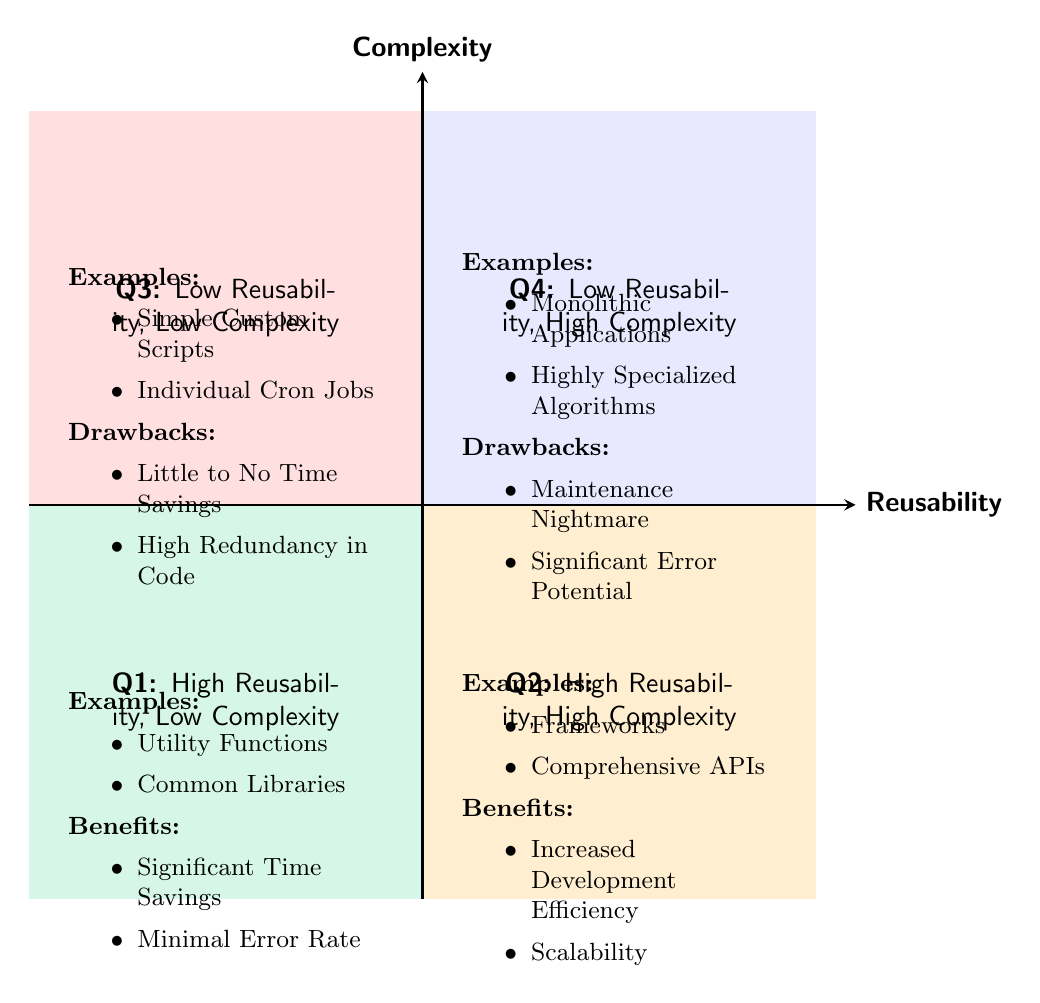What are the examples listed in Quadrant 1? The examples for Quadrant 1, which represents "High Reusability, Low Complexity," are clearly stated in the diagram as "Utility Functions" and "Common Libraries."
Answer: Utility Functions, Common Libraries What is the primary benefit associated with Quadrant 2? Quadrant 2, labeled "High Reusability, High Complexity," lists "Increased Development Efficiency" and "Scalability" as its benefits, but the primary benefit mentioned is "Increased Development Efficiency."
Answer: Increased Development Efficiency What is the complexity level of the code modules in Quadrant 3? Quadrant 3 is defined as "Low Reusability, Low Complexity," indicating that the complexity level is low based on the quadrant's title.
Answer: Low How many examples are provided in Quadrant 4? Quadrant 4 contains "Monolithic Applications" and "Highly Specialized Algorithms" as its examples, leading to a total of two examples being provided.
Answer: Two What would be the consequence of using code modules in Quadrant 4? The drawbacks of Quadrant 4, which are "Maintenance Nightmare" and "Significant Error Potential," indicate that using code modules in this quadrant would lead to serious issues.
Answer: Maintenance Nightmare, Significant Error Potential Which quadrant is characterized by minimal error rate? Quadrant 1 is characterized by "Minimal Error Rate," as listed among its benefits, clearly distinguishing it in terms of reliability.
Answer: Quadrant 1 What is the relationship between reusability and complexity in Quadrant 3? Quadrant 3 demonstrates that there is low reusability and low complexity, establishing a relationship where neither characteristic provides any substantial benefit for code modules in that category.
Answer: Low reusability, Low complexity Which quadrant would likely provide significant time savings? Quadrant 1, described as "High Reusability, Low Complexity," is indicated to provide "Significant Time Savings" among its benefits, making it the quadrant that is most likely to be effective in saving time.
Answer: Quadrant 1 How many quadrants are indicated in this chart? The diagram clearly delineates four quadrants, labeled Q1, Q2, Q3, and Q4 respectively, confirming that there are four distinct areas in the chart.
Answer: Four 